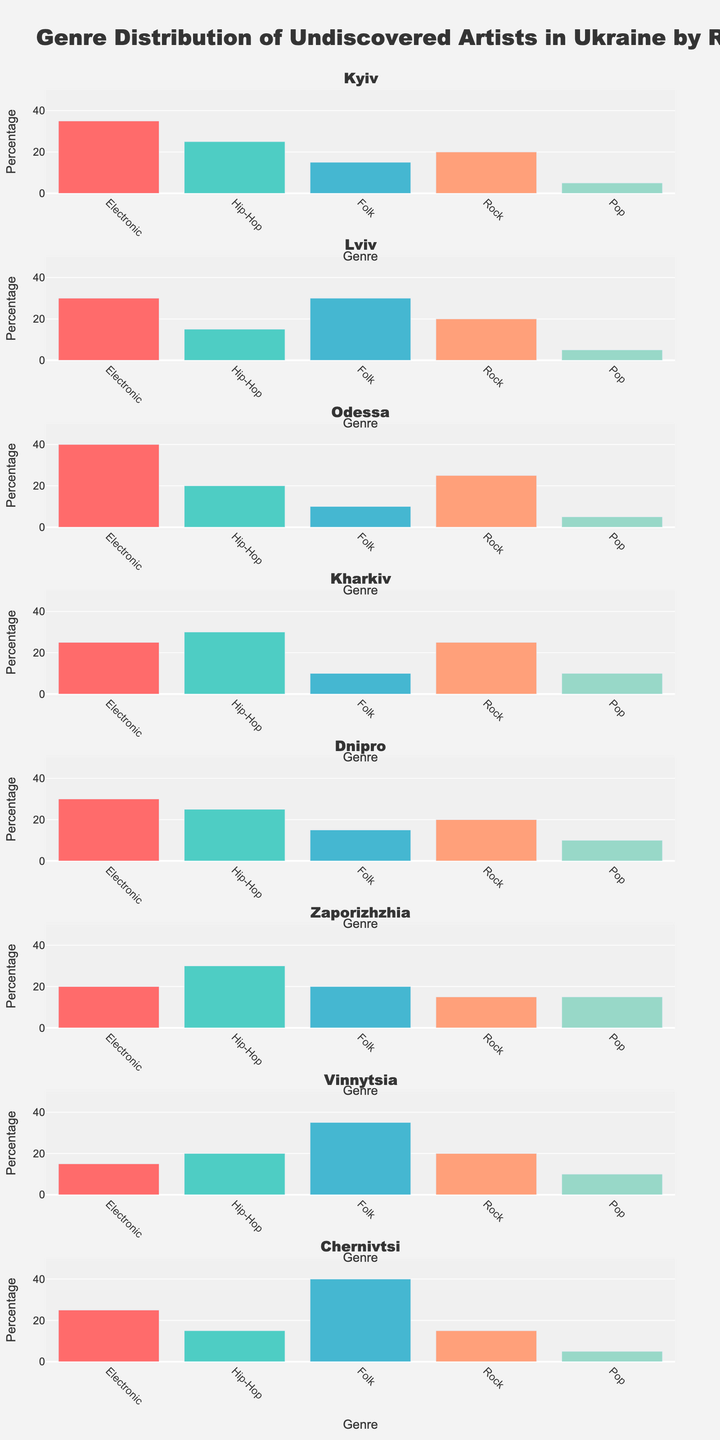How many regions are displayed in the figure? By counting the number of subplot titles, we can see how many regions are represented. Each subplot has a title corresponding to a different region.
Answer: 8 What genre has the highest proportion in Lviv and what is its value? By locating the Lviv subplot and examining the bars, we see that Folk has the tallest bar.
Answer: Folk, 30 Which region has the highest proportion of Pop genre? By comparing the heights of the Pop genre bars across all subplots, Zaporizhzhia has the tallest bar for Pop.
Answer: Zaporizhzhia What is the combined percentage of Rock genre in Kyiv, Odessa, and Kharkiv? Summing up the values for Rock in these three regions: Kyiv (20) + Odessa (25) + Kharkiv (25) = 70
Answer: 70 Comparing Chernivtsi and Vinnytsia, which region has a higher proportion of Electronic genre? By examining the height of the Electronic genre bars in both subplots, Chernivtsi has a taller bar for Electronic.
Answer: Chernivtsi Which genre has a consistent distribution of 10% across more than one region? By scanning the figures, we see that Pop has exactly 10% in Dnipro, Kharkiv, and Vinnytsia.
Answer: Pop What is the average proportion of Hip-Hop genre across Dnipro, Vinnytsia, and Zaporizhzhia? Using the values for Hip-Hop across these regions: (25 + 20 + 30) / 3 = 25
Answer: 25 Which region has the lowest proportion of Folk genre? Comparing the heights of the Folk genre bars in all subplots, Odessa and Kharkiv both have the shortest Folk bars with a value of 10.
Answer: Odessa or Kharkiv 